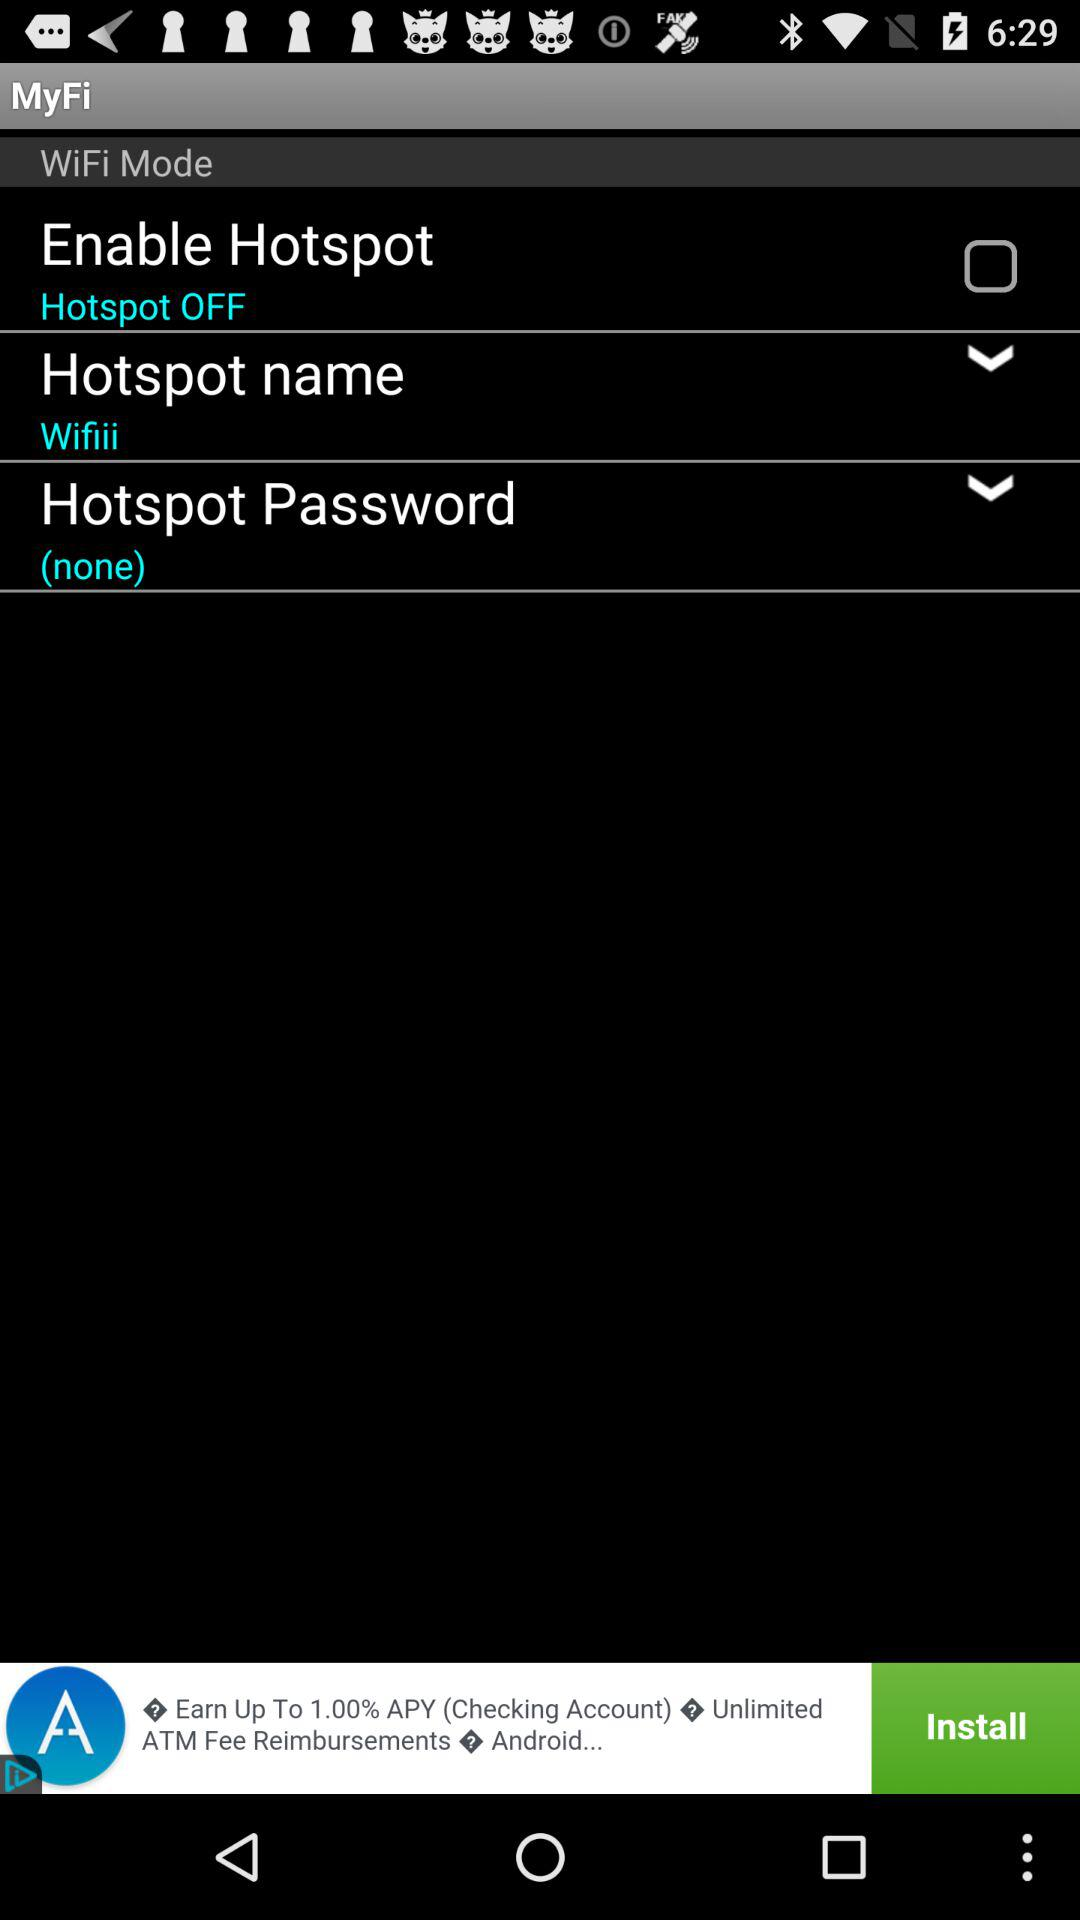How many unselected checkboxes are there on this screen?
Answer the question using a single word or phrase. 1 